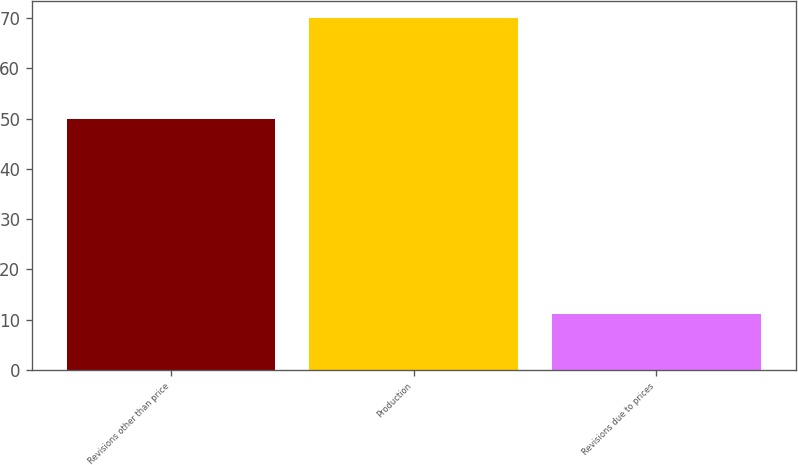Convert chart. <chart><loc_0><loc_0><loc_500><loc_500><bar_chart><fcel>Revisions other than price<fcel>Production<fcel>Revisions due to prices<nl><fcel>50<fcel>70<fcel>11<nl></chart> 